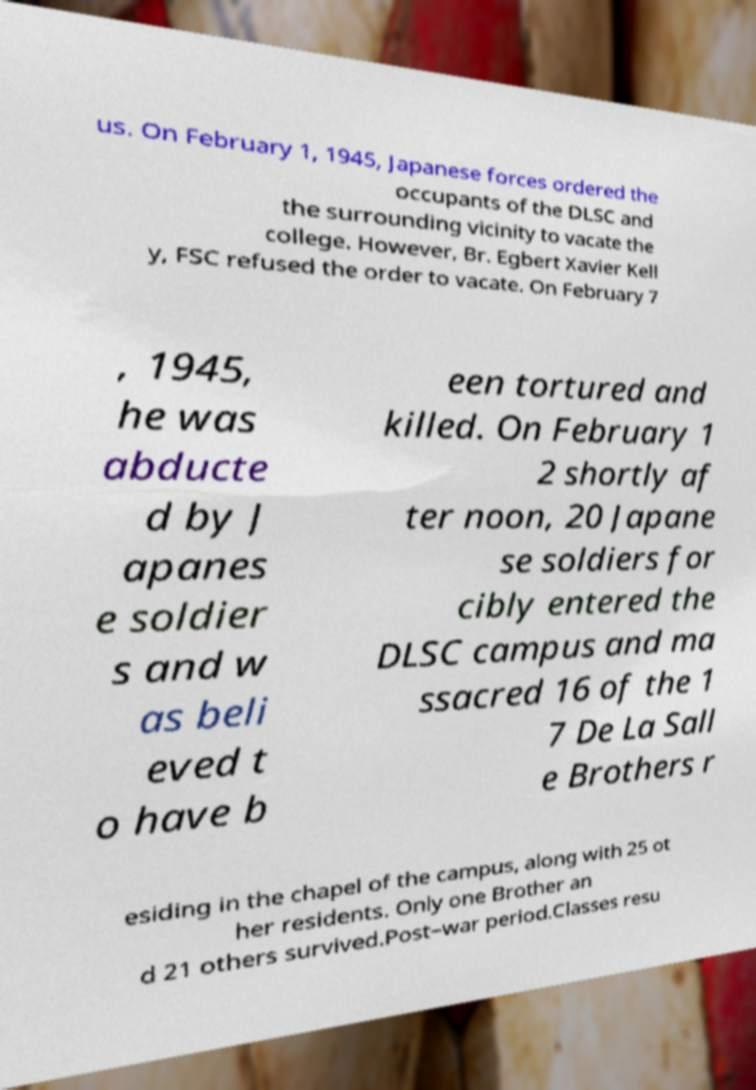Could you assist in decoding the text presented in this image and type it out clearly? us. On February 1, 1945, Japanese forces ordered the occupants of the DLSC and the surrounding vicinity to vacate the college. However, Br. Egbert Xavier Kell y, FSC refused the order to vacate. On February 7 , 1945, he was abducte d by J apanes e soldier s and w as beli eved t o have b een tortured and killed. On February 1 2 shortly af ter noon, 20 Japane se soldiers for cibly entered the DLSC campus and ma ssacred 16 of the 1 7 De La Sall e Brothers r esiding in the chapel of the campus, along with 25 ot her residents. Only one Brother an d 21 others survived.Post–war period.Classes resu 